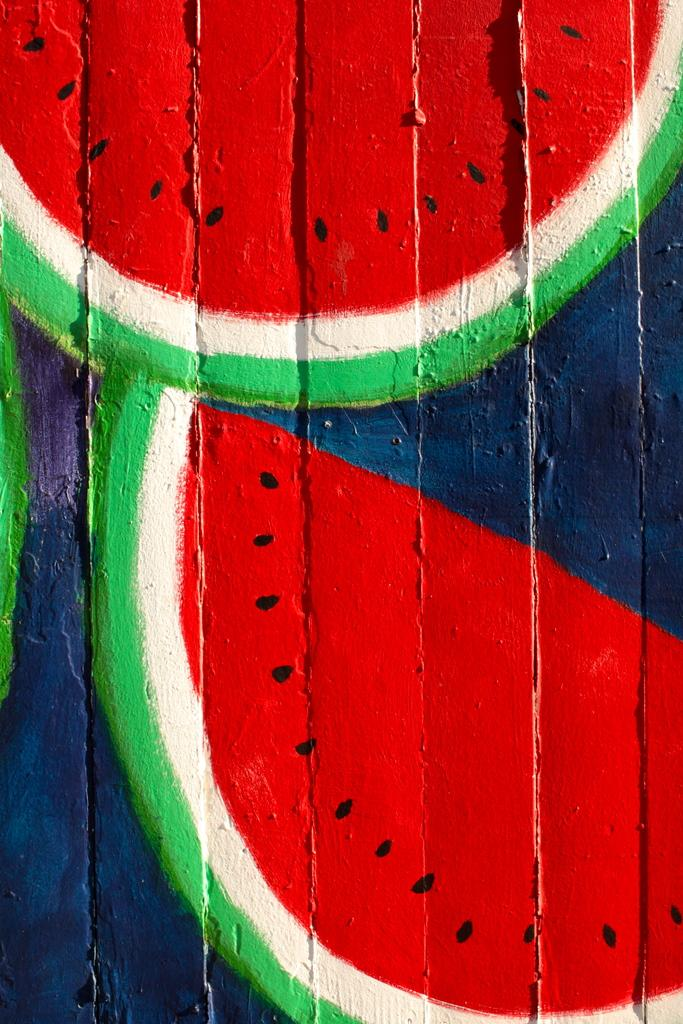What type of surface is visible in the image? There is a wooden surface in the image. What is on the wooden surface? There is a painting on the wooden surface. What does the painting depict? The painting depicts a sliced watermelon. What colors are used in the painting? The colors in the painting include red, black, white, green, and blue. What type of oatmeal is being prepared in the image? There is no oatmeal present in the image; it features a painting of a sliced watermelon on a wooden surface. 